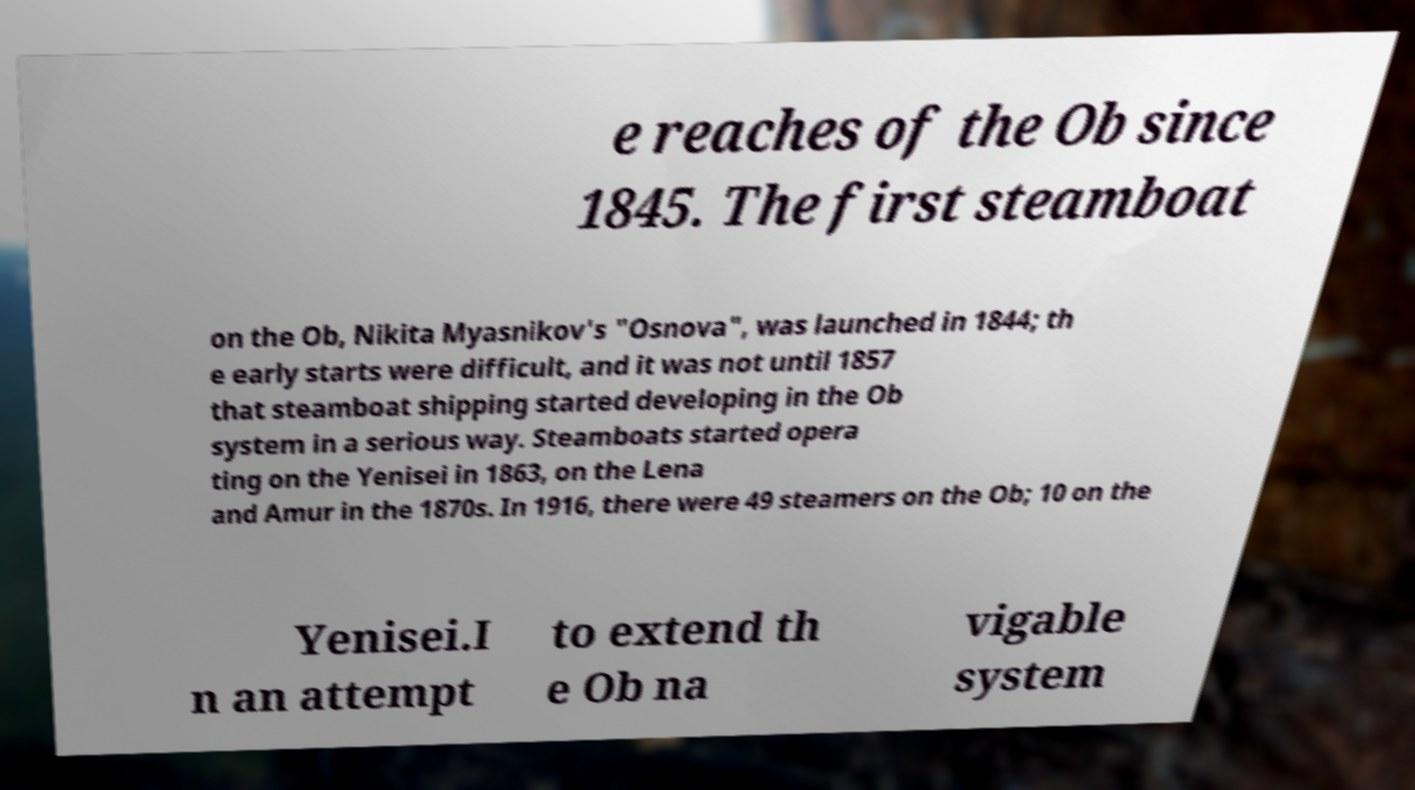Can you accurately transcribe the text from the provided image for me? e reaches of the Ob since 1845. The first steamboat on the Ob, Nikita Myasnikov's "Osnova", was launched in 1844; th e early starts were difficult, and it was not until 1857 that steamboat shipping started developing in the Ob system in a serious way. Steamboats started opera ting on the Yenisei in 1863, on the Lena and Amur in the 1870s. In 1916, there were 49 steamers on the Ob; 10 on the Yenisei.I n an attempt to extend th e Ob na vigable system 